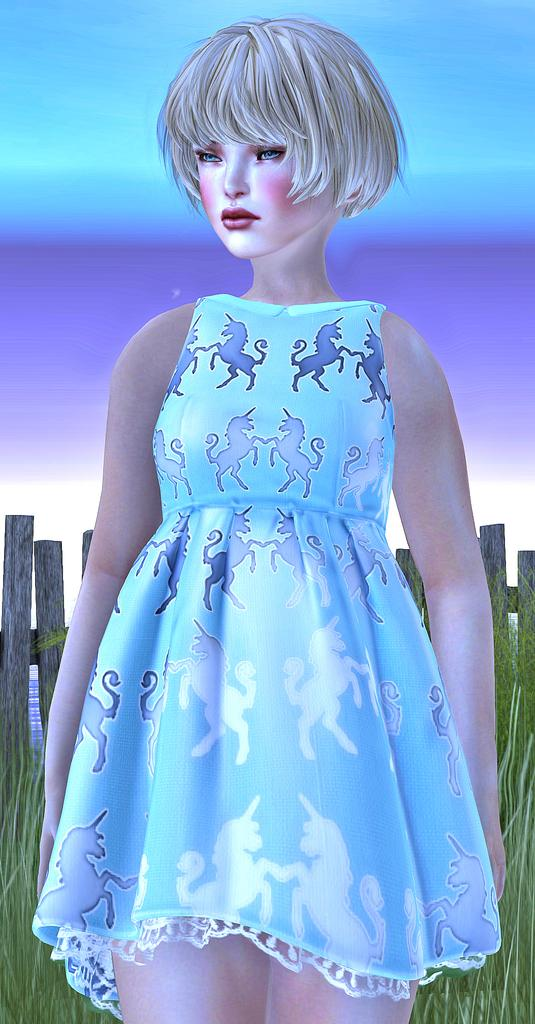What type of picture is the image? The image is an animated picture. Who is present in the image? There is a girl in the image. What type of terrain is visible in the image? There is grass in the image. What objects can be seen in the image? There are wooden sticks in the image. What type of glue is the girl using in the image? There is no glue present in the image. Can you read the note that the girl is holding in the image? There is no note present in the image. 